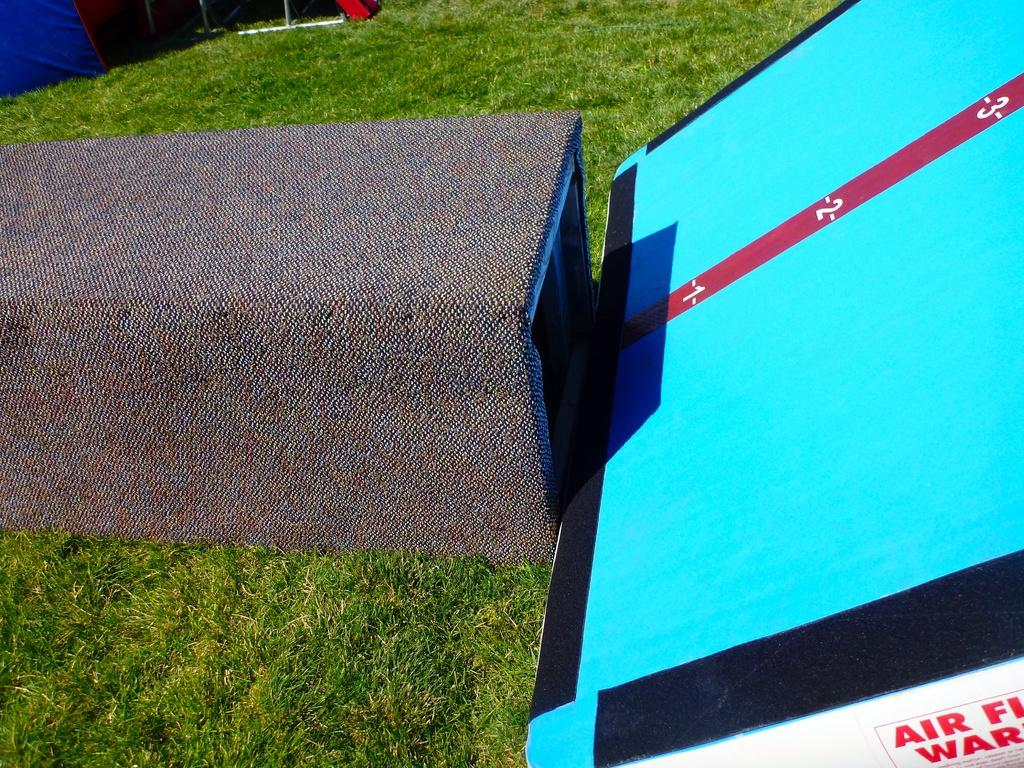What colors can be seen on the board in the image? The board in the image has blue, black, and red colors. What type of information is present on the board? Numbers are present on the board. What is located in front of the board? There is a box in front of the board. What type of vegetation is visible in the image? Green grass is visible in the image. What can be seen on the back side of the board? There are objects visible on the back side of the board. What type of joke is being told by the jeans in the image? There are no jeans present in the image, and therefore no jokes can be told by them. 